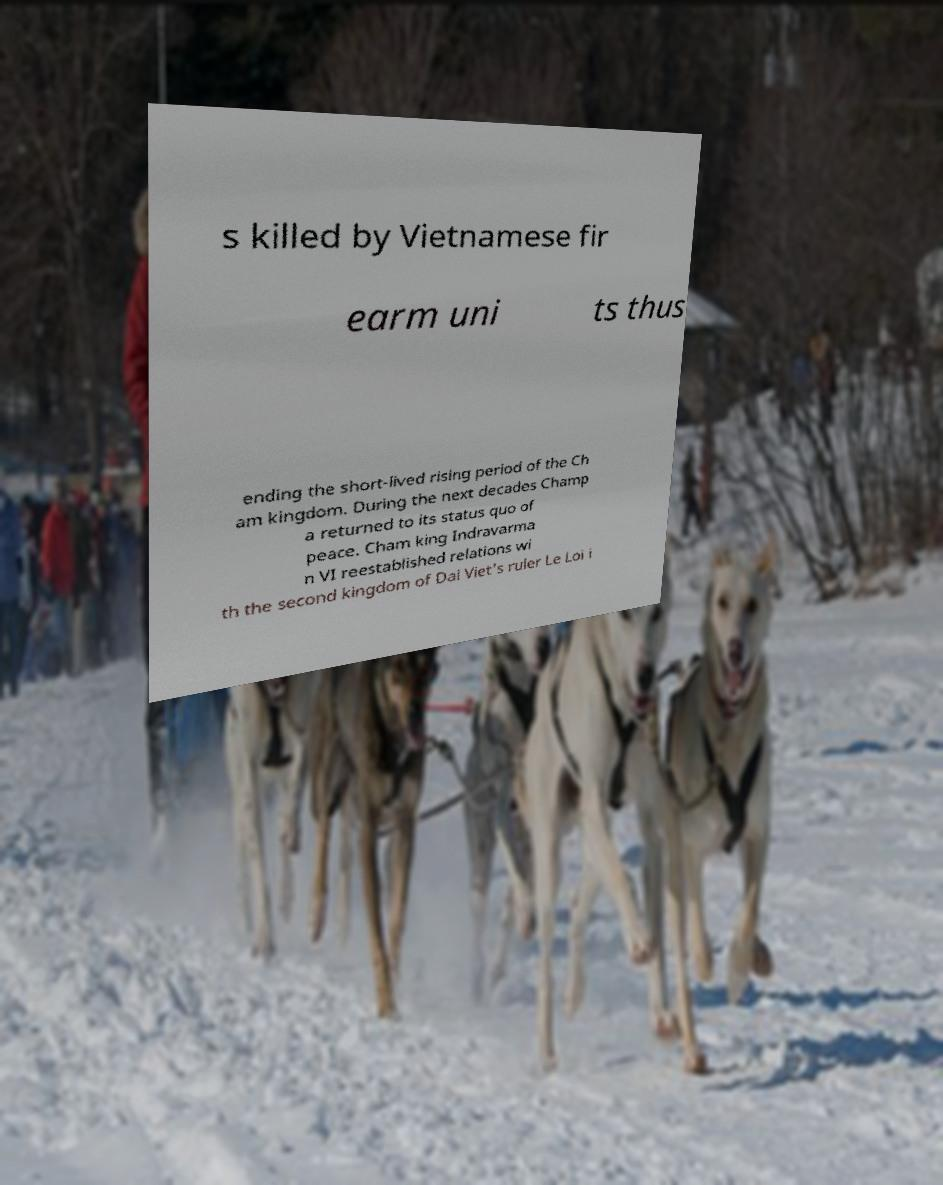Please identify and transcribe the text found in this image. s killed by Vietnamese fir earm uni ts thus ending the short-lived rising period of the Ch am kingdom. During the next decades Champ a returned to its status quo of peace. Cham king Indravarma n VI reestablished relations wi th the second kingdom of Dai Viet's ruler Le Loi i 